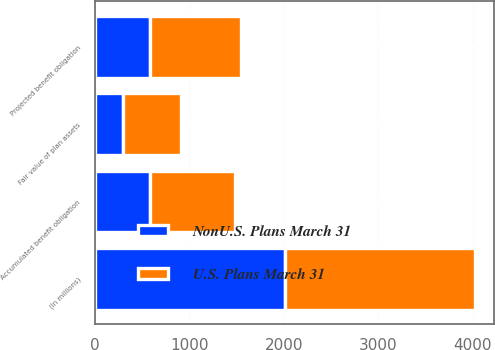Convert chart. <chart><loc_0><loc_0><loc_500><loc_500><stacked_bar_chart><ecel><fcel>(In millions)<fcel>Projected benefit obligation<fcel>Accumulated benefit obligation<fcel>Fair value of plan assets<nl><fcel>NonU.S. Plans March 31<fcel>2015<fcel>583<fcel>583<fcel>298<nl><fcel>U.S. Plans March 31<fcel>2015<fcel>963<fcel>897<fcel>612<nl></chart> 